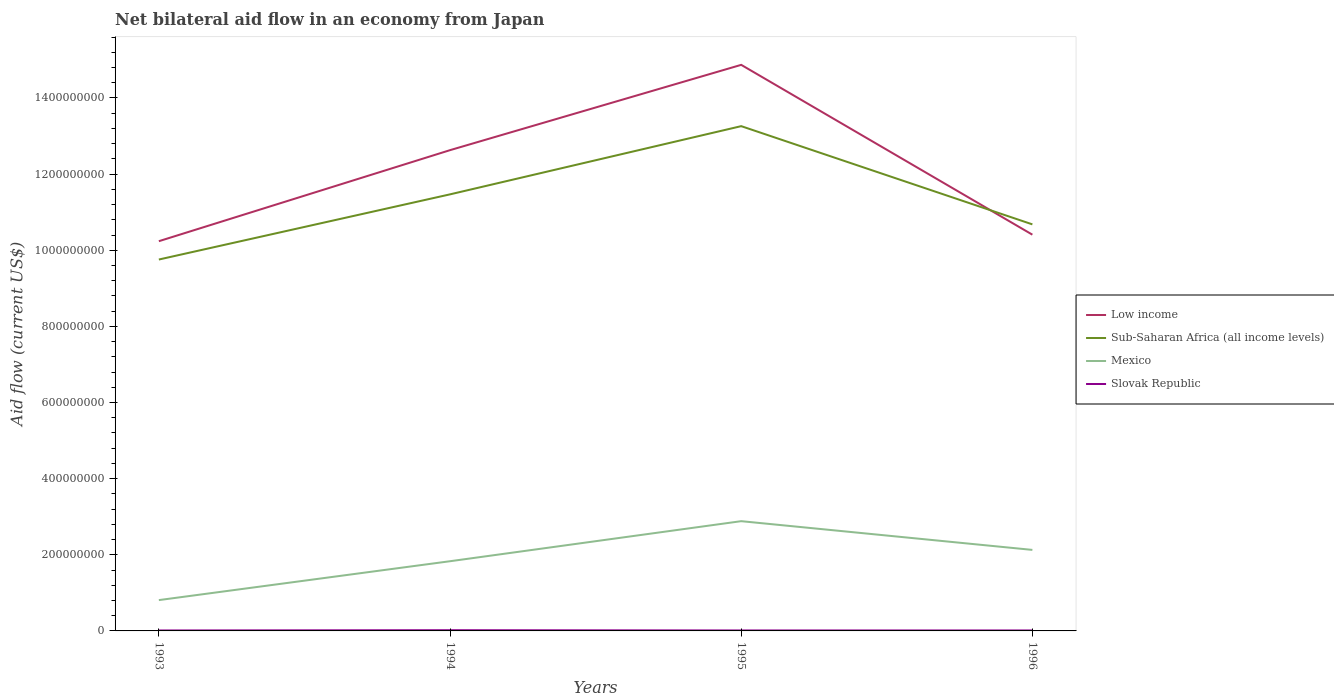Across all years, what is the maximum net bilateral aid flow in Slovak Republic?
Your response must be concise. 1.20e+06. What is the total net bilateral aid flow in Sub-Saharan Africa (all income levels) in the graph?
Keep it short and to the point. -3.50e+08. What is the difference between the highest and the second highest net bilateral aid flow in Mexico?
Your answer should be very brief. 2.07e+08. What is the difference between the highest and the lowest net bilateral aid flow in Mexico?
Make the answer very short. 2. What is the difference between two consecutive major ticks on the Y-axis?
Offer a very short reply. 2.00e+08. Are the values on the major ticks of Y-axis written in scientific E-notation?
Ensure brevity in your answer.  No. How many legend labels are there?
Offer a very short reply. 4. How are the legend labels stacked?
Give a very brief answer. Vertical. What is the title of the graph?
Make the answer very short. Net bilateral aid flow in an economy from Japan. Does "Peru" appear as one of the legend labels in the graph?
Provide a short and direct response. No. What is the label or title of the Y-axis?
Ensure brevity in your answer.  Aid flow (current US$). What is the Aid flow (current US$) in Low income in 1993?
Give a very brief answer. 1.02e+09. What is the Aid flow (current US$) of Sub-Saharan Africa (all income levels) in 1993?
Offer a terse response. 9.76e+08. What is the Aid flow (current US$) of Mexico in 1993?
Keep it short and to the point. 8.09e+07. What is the Aid flow (current US$) of Slovak Republic in 1993?
Offer a terse response. 1.20e+06. What is the Aid flow (current US$) in Low income in 1994?
Your answer should be very brief. 1.26e+09. What is the Aid flow (current US$) of Sub-Saharan Africa (all income levels) in 1994?
Provide a short and direct response. 1.15e+09. What is the Aid flow (current US$) of Mexico in 1994?
Offer a very short reply. 1.83e+08. What is the Aid flow (current US$) of Slovak Republic in 1994?
Your response must be concise. 1.89e+06. What is the Aid flow (current US$) in Low income in 1995?
Your response must be concise. 1.49e+09. What is the Aid flow (current US$) in Sub-Saharan Africa (all income levels) in 1995?
Provide a succinct answer. 1.33e+09. What is the Aid flow (current US$) of Mexico in 1995?
Keep it short and to the point. 2.88e+08. What is the Aid flow (current US$) in Slovak Republic in 1995?
Your answer should be compact. 1.24e+06. What is the Aid flow (current US$) in Low income in 1996?
Offer a very short reply. 1.04e+09. What is the Aid flow (current US$) in Sub-Saharan Africa (all income levels) in 1996?
Your answer should be compact. 1.07e+09. What is the Aid flow (current US$) in Mexico in 1996?
Keep it short and to the point. 2.13e+08. What is the Aid flow (current US$) of Slovak Republic in 1996?
Your answer should be compact. 1.22e+06. Across all years, what is the maximum Aid flow (current US$) of Low income?
Provide a short and direct response. 1.49e+09. Across all years, what is the maximum Aid flow (current US$) in Sub-Saharan Africa (all income levels)?
Offer a very short reply. 1.33e+09. Across all years, what is the maximum Aid flow (current US$) of Mexico?
Offer a very short reply. 2.88e+08. Across all years, what is the maximum Aid flow (current US$) in Slovak Republic?
Your answer should be compact. 1.89e+06. Across all years, what is the minimum Aid flow (current US$) of Low income?
Give a very brief answer. 1.02e+09. Across all years, what is the minimum Aid flow (current US$) of Sub-Saharan Africa (all income levels)?
Make the answer very short. 9.76e+08. Across all years, what is the minimum Aid flow (current US$) of Mexico?
Your response must be concise. 8.09e+07. Across all years, what is the minimum Aid flow (current US$) of Slovak Republic?
Provide a succinct answer. 1.20e+06. What is the total Aid flow (current US$) of Low income in the graph?
Offer a terse response. 4.81e+09. What is the total Aid flow (current US$) in Sub-Saharan Africa (all income levels) in the graph?
Offer a very short reply. 4.52e+09. What is the total Aid flow (current US$) in Mexico in the graph?
Keep it short and to the point. 7.65e+08. What is the total Aid flow (current US$) in Slovak Republic in the graph?
Make the answer very short. 5.55e+06. What is the difference between the Aid flow (current US$) in Low income in 1993 and that in 1994?
Your answer should be compact. -2.39e+08. What is the difference between the Aid flow (current US$) in Sub-Saharan Africa (all income levels) in 1993 and that in 1994?
Your answer should be compact. -1.71e+08. What is the difference between the Aid flow (current US$) of Mexico in 1993 and that in 1994?
Provide a short and direct response. -1.02e+08. What is the difference between the Aid flow (current US$) of Slovak Republic in 1993 and that in 1994?
Your answer should be compact. -6.90e+05. What is the difference between the Aid flow (current US$) in Low income in 1993 and that in 1995?
Give a very brief answer. -4.63e+08. What is the difference between the Aid flow (current US$) of Sub-Saharan Africa (all income levels) in 1993 and that in 1995?
Provide a short and direct response. -3.50e+08. What is the difference between the Aid flow (current US$) of Mexico in 1993 and that in 1995?
Provide a short and direct response. -2.07e+08. What is the difference between the Aid flow (current US$) in Slovak Republic in 1993 and that in 1995?
Offer a terse response. -4.00e+04. What is the difference between the Aid flow (current US$) in Low income in 1993 and that in 1996?
Provide a short and direct response. -1.71e+07. What is the difference between the Aid flow (current US$) of Sub-Saharan Africa (all income levels) in 1993 and that in 1996?
Give a very brief answer. -9.23e+07. What is the difference between the Aid flow (current US$) of Mexico in 1993 and that in 1996?
Ensure brevity in your answer.  -1.32e+08. What is the difference between the Aid flow (current US$) of Slovak Republic in 1993 and that in 1996?
Ensure brevity in your answer.  -2.00e+04. What is the difference between the Aid flow (current US$) in Low income in 1994 and that in 1995?
Offer a very short reply. -2.24e+08. What is the difference between the Aid flow (current US$) of Sub-Saharan Africa (all income levels) in 1994 and that in 1995?
Make the answer very short. -1.79e+08. What is the difference between the Aid flow (current US$) in Mexico in 1994 and that in 1995?
Keep it short and to the point. -1.05e+08. What is the difference between the Aid flow (current US$) in Slovak Republic in 1994 and that in 1995?
Your answer should be compact. 6.50e+05. What is the difference between the Aid flow (current US$) in Low income in 1994 and that in 1996?
Keep it short and to the point. 2.22e+08. What is the difference between the Aid flow (current US$) in Sub-Saharan Africa (all income levels) in 1994 and that in 1996?
Offer a very short reply. 7.88e+07. What is the difference between the Aid flow (current US$) in Mexico in 1994 and that in 1996?
Your answer should be compact. -2.98e+07. What is the difference between the Aid flow (current US$) in Slovak Republic in 1994 and that in 1996?
Give a very brief answer. 6.70e+05. What is the difference between the Aid flow (current US$) of Low income in 1995 and that in 1996?
Keep it short and to the point. 4.46e+08. What is the difference between the Aid flow (current US$) in Sub-Saharan Africa (all income levels) in 1995 and that in 1996?
Provide a short and direct response. 2.58e+08. What is the difference between the Aid flow (current US$) of Mexico in 1995 and that in 1996?
Make the answer very short. 7.54e+07. What is the difference between the Aid flow (current US$) of Low income in 1993 and the Aid flow (current US$) of Sub-Saharan Africa (all income levels) in 1994?
Ensure brevity in your answer.  -1.23e+08. What is the difference between the Aid flow (current US$) in Low income in 1993 and the Aid flow (current US$) in Mexico in 1994?
Keep it short and to the point. 8.41e+08. What is the difference between the Aid flow (current US$) in Low income in 1993 and the Aid flow (current US$) in Slovak Republic in 1994?
Your answer should be very brief. 1.02e+09. What is the difference between the Aid flow (current US$) of Sub-Saharan Africa (all income levels) in 1993 and the Aid flow (current US$) of Mexico in 1994?
Provide a succinct answer. 7.93e+08. What is the difference between the Aid flow (current US$) in Sub-Saharan Africa (all income levels) in 1993 and the Aid flow (current US$) in Slovak Republic in 1994?
Offer a terse response. 9.74e+08. What is the difference between the Aid flow (current US$) of Mexico in 1993 and the Aid flow (current US$) of Slovak Republic in 1994?
Your answer should be very brief. 7.90e+07. What is the difference between the Aid flow (current US$) of Low income in 1993 and the Aid flow (current US$) of Sub-Saharan Africa (all income levels) in 1995?
Your response must be concise. -3.02e+08. What is the difference between the Aid flow (current US$) in Low income in 1993 and the Aid flow (current US$) in Mexico in 1995?
Provide a succinct answer. 7.35e+08. What is the difference between the Aid flow (current US$) in Low income in 1993 and the Aid flow (current US$) in Slovak Republic in 1995?
Make the answer very short. 1.02e+09. What is the difference between the Aid flow (current US$) in Sub-Saharan Africa (all income levels) in 1993 and the Aid flow (current US$) in Mexico in 1995?
Provide a succinct answer. 6.87e+08. What is the difference between the Aid flow (current US$) of Sub-Saharan Africa (all income levels) in 1993 and the Aid flow (current US$) of Slovak Republic in 1995?
Your answer should be compact. 9.74e+08. What is the difference between the Aid flow (current US$) of Mexico in 1993 and the Aid flow (current US$) of Slovak Republic in 1995?
Your answer should be compact. 7.97e+07. What is the difference between the Aid flow (current US$) in Low income in 1993 and the Aid flow (current US$) in Sub-Saharan Africa (all income levels) in 1996?
Provide a short and direct response. -4.42e+07. What is the difference between the Aid flow (current US$) in Low income in 1993 and the Aid flow (current US$) in Mexico in 1996?
Give a very brief answer. 8.11e+08. What is the difference between the Aid flow (current US$) in Low income in 1993 and the Aid flow (current US$) in Slovak Republic in 1996?
Keep it short and to the point. 1.02e+09. What is the difference between the Aid flow (current US$) of Sub-Saharan Africa (all income levels) in 1993 and the Aid flow (current US$) of Mexico in 1996?
Provide a succinct answer. 7.63e+08. What is the difference between the Aid flow (current US$) of Sub-Saharan Africa (all income levels) in 1993 and the Aid flow (current US$) of Slovak Republic in 1996?
Provide a succinct answer. 9.74e+08. What is the difference between the Aid flow (current US$) in Mexico in 1993 and the Aid flow (current US$) in Slovak Republic in 1996?
Keep it short and to the point. 7.97e+07. What is the difference between the Aid flow (current US$) in Low income in 1994 and the Aid flow (current US$) in Sub-Saharan Africa (all income levels) in 1995?
Offer a terse response. -6.30e+07. What is the difference between the Aid flow (current US$) in Low income in 1994 and the Aid flow (current US$) in Mexico in 1995?
Provide a succinct answer. 9.75e+08. What is the difference between the Aid flow (current US$) in Low income in 1994 and the Aid flow (current US$) in Slovak Republic in 1995?
Provide a succinct answer. 1.26e+09. What is the difference between the Aid flow (current US$) in Sub-Saharan Africa (all income levels) in 1994 and the Aid flow (current US$) in Mexico in 1995?
Your answer should be very brief. 8.58e+08. What is the difference between the Aid flow (current US$) of Sub-Saharan Africa (all income levels) in 1994 and the Aid flow (current US$) of Slovak Republic in 1995?
Your response must be concise. 1.15e+09. What is the difference between the Aid flow (current US$) in Mexico in 1994 and the Aid flow (current US$) in Slovak Republic in 1995?
Provide a short and direct response. 1.82e+08. What is the difference between the Aid flow (current US$) of Low income in 1994 and the Aid flow (current US$) of Sub-Saharan Africa (all income levels) in 1996?
Keep it short and to the point. 1.95e+08. What is the difference between the Aid flow (current US$) of Low income in 1994 and the Aid flow (current US$) of Mexico in 1996?
Your answer should be compact. 1.05e+09. What is the difference between the Aid flow (current US$) of Low income in 1994 and the Aid flow (current US$) of Slovak Republic in 1996?
Your answer should be very brief. 1.26e+09. What is the difference between the Aid flow (current US$) of Sub-Saharan Africa (all income levels) in 1994 and the Aid flow (current US$) of Mexico in 1996?
Provide a short and direct response. 9.34e+08. What is the difference between the Aid flow (current US$) of Sub-Saharan Africa (all income levels) in 1994 and the Aid flow (current US$) of Slovak Republic in 1996?
Offer a terse response. 1.15e+09. What is the difference between the Aid flow (current US$) in Mexico in 1994 and the Aid flow (current US$) in Slovak Republic in 1996?
Your response must be concise. 1.82e+08. What is the difference between the Aid flow (current US$) in Low income in 1995 and the Aid flow (current US$) in Sub-Saharan Africa (all income levels) in 1996?
Offer a very short reply. 4.19e+08. What is the difference between the Aid flow (current US$) in Low income in 1995 and the Aid flow (current US$) in Mexico in 1996?
Offer a very short reply. 1.27e+09. What is the difference between the Aid flow (current US$) of Low income in 1995 and the Aid flow (current US$) of Slovak Republic in 1996?
Your answer should be very brief. 1.49e+09. What is the difference between the Aid flow (current US$) of Sub-Saharan Africa (all income levels) in 1995 and the Aid flow (current US$) of Mexico in 1996?
Your response must be concise. 1.11e+09. What is the difference between the Aid flow (current US$) of Sub-Saharan Africa (all income levels) in 1995 and the Aid flow (current US$) of Slovak Republic in 1996?
Make the answer very short. 1.32e+09. What is the difference between the Aid flow (current US$) in Mexico in 1995 and the Aid flow (current US$) in Slovak Republic in 1996?
Offer a very short reply. 2.87e+08. What is the average Aid flow (current US$) in Low income per year?
Give a very brief answer. 1.20e+09. What is the average Aid flow (current US$) in Sub-Saharan Africa (all income levels) per year?
Your response must be concise. 1.13e+09. What is the average Aid flow (current US$) of Mexico per year?
Give a very brief answer. 1.91e+08. What is the average Aid flow (current US$) of Slovak Republic per year?
Provide a succinct answer. 1.39e+06. In the year 1993, what is the difference between the Aid flow (current US$) in Low income and Aid flow (current US$) in Sub-Saharan Africa (all income levels)?
Ensure brevity in your answer.  4.81e+07. In the year 1993, what is the difference between the Aid flow (current US$) of Low income and Aid flow (current US$) of Mexico?
Offer a very short reply. 9.43e+08. In the year 1993, what is the difference between the Aid flow (current US$) of Low income and Aid flow (current US$) of Slovak Republic?
Offer a terse response. 1.02e+09. In the year 1993, what is the difference between the Aid flow (current US$) of Sub-Saharan Africa (all income levels) and Aid flow (current US$) of Mexico?
Ensure brevity in your answer.  8.95e+08. In the year 1993, what is the difference between the Aid flow (current US$) of Sub-Saharan Africa (all income levels) and Aid flow (current US$) of Slovak Republic?
Provide a succinct answer. 9.74e+08. In the year 1993, what is the difference between the Aid flow (current US$) in Mexico and Aid flow (current US$) in Slovak Republic?
Ensure brevity in your answer.  7.97e+07. In the year 1994, what is the difference between the Aid flow (current US$) of Low income and Aid flow (current US$) of Sub-Saharan Africa (all income levels)?
Your answer should be compact. 1.16e+08. In the year 1994, what is the difference between the Aid flow (current US$) of Low income and Aid flow (current US$) of Mexico?
Provide a short and direct response. 1.08e+09. In the year 1994, what is the difference between the Aid flow (current US$) of Low income and Aid flow (current US$) of Slovak Republic?
Give a very brief answer. 1.26e+09. In the year 1994, what is the difference between the Aid flow (current US$) of Sub-Saharan Africa (all income levels) and Aid flow (current US$) of Mexico?
Keep it short and to the point. 9.64e+08. In the year 1994, what is the difference between the Aid flow (current US$) in Sub-Saharan Africa (all income levels) and Aid flow (current US$) in Slovak Republic?
Your answer should be compact. 1.14e+09. In the year 1994, what is the difference between the Aid flow (current US$) in Mexico and Aid flow (current US$) in Slovak Republic?
Your response must be concise. 1.81e+08. In the year 1995, what is the difference between the Aid flow (current US$) of Low income and Aid flow (current US$) of Sub-Saharan Africa (all income levels)?
Provide a short and direct response. 1.61e+08. In the year 1995, what is the difference between the Aid flow (current US$) in Low income and Aid flow (current US$) in Mexico?
Provide a short and direct response. 1.20e+09. In the year 1995, what is the difference between the Aid flow (current US$) of Low income and Aid flow (current US$) of Slovak Republic?
Provide a succinct answer. 1.49e+09. In the year 1995, what is the difference between the Aid flow (current US$) in Sub-Saharan Africa (all income levels) and Aid flow (current US$) in Mexico?
Ensure brevity in your answer.  1.04e+09. In the year 1995, what is the difference between the Aid flow (current US$) of Sub-Saharan Africa (all income levels) and Aid flow (current US$) of Slovak Republic?
Offer a very short reply. 1.32e+09. In the year 1995, what is the difference between the Aid flow (current US$) of Mexico and Aid flow (current US$) of Slovak Republic?
Your answer should be compact. 2.87e+08. In the year 1996, what is the difference between the Aid flow (current US$) in Low income and Aid flow (current US$) in Sub-Saharan Africa (all income levels)?
Make the answer very short. -2.71e+07. In the year 1996, what is the difference between the Aid flow (current US$) in Low income and Aid flow (current US$) in Mexico?
Make the answer very short. 8.28e+08. In the year 1996, what is the difference between the Aid flow (current US$) of Low income and Aid flow (current US$) of Slovak Republic?
Give a very brief answer. 1.04e+09. In the year 1996, what is the difference between the Aid flow (current US$) of Sub-Saharan Africa (all income levels) and Aid flow (current US$) of Mexico?
Offer a very short reply. 8.55e+08. In the year 1996, what is the difference between the Aid flow (current US$) of Sub-Saharan Africa (all income levels) and Aid flow (current US$) of Slovak Republic?
Offer a very short reply. 1.07e+09. In the year 1996, what is the difference between the Aid flow (current US$) of Mexico and Aid flow (current US$) of Slovak Republic?
Make the answer very short. 2.12e+08. What is the ratio of the Aid flow (current US$) of Low income in 1993 to that in 1994?
Keep it short and to the point. 0.81. What is the ratio of the Aid flow (current US$) of Sub-Saharan Africa (all income levels) in 1993 to that in 1994?
Your answer should be compact. 0.85. What is the ratio of the Aid flow (current US$) in Mexico in 1993 to that in 1994?
Your answer should be very brief. 0.44. What is the ratio of the Aid flow (current US$) of Slovak Republic in 1993 to that in 1994?
Offer a terse response. 0.63. What is the ratio of the Aid flow (current US$) of Low income in 1993 to that in 1995?
Your answer should be compact. 0.69. What is the ratio of the Aid flow (current US$) in Sub-Saharan Africa (all income levels) in 1993 to that in 1995?
Your response must be concise. 0.74. What is the ratio of the Aid flow (current US$) of Mexico in 1993 to that in 1995?
Keep it short and to the point. 0.28. What is the ratio of the Aid flow (current US$) in Low income in 1993 to that in 1996?
Keep it short and to the point. 0.98. What is the ratio of the Aid flow (current US$) in Sub-Saharan Africa (all income levels) in 1993 to that in 1996?
Ensure brevity in your answer.  0.91. What is the ratio of the Aid flow (current US$) of Mexico in 1993 to that in 1996?
Your answer should be very brief. 0.38. What is the ratio of the Aid flow (current US$) in Slovak Republic in 1993 to that in 1996?
Make the answer very short. 0.98. What is the ratio of the Aid flow (current US$) in Low income in 1994 to that in 1995?
Your answer should be very brief. 0.85. What is the ratio of the Aid flow (current US$) of Sub-Saharan Africa (all income levels) in 1994 to that in 1995?
Offer a terse response. 0.86. What is the ratio of the Aid flow (current US$) of Mexico in 1994 to that in 1995?
Offer a terse response. 0.64. What is the ratio of the Aid flow (current US$) of Slovak Republic in 1994 to that in 1995?
Your answer should be compact. 1.52. What is the ratio of the Aid flow (current US$) of Low income in 1994 to that in 1996?
Keep it short and to the point. 1.21. What is the ratio of the Aid flow (current US$) of Sub-Saharan Africa (all income levels) in 1994 to that in 1996?
Ensure brevity in your answer.  1.07. What is the ratio of the Aid flow (current US$) of Mexico in 1994 to that in 1996?
Make the answer very short. 0.86. What is the ratio of the Aid flow (current US$) of Slovak Republic in 1994 to that in 1996?
Provide a short and direct response. 1.55. What is the ratio of the Aid flow (current US$) in Low income in 1995 to that in 1996?
Offer a terse response. 1.43. What is the ratio of the Aid flow (current US$) in Sub-Saharan Africa (all income levels) in 1995 to that in 1996?
Provide a short and direct response. 1.24. What is the ratio of the Aid flow (current US$) in Mexico in 1995 to that in 1996?
Keep it short and to the point. 1.35. What is the ratio of the Aid flow (current US$) of Slovak Republic in 1995 to that in 1996?
Provide a succinct answer. 1.02. What is the difference between the highest and the second highest Aid flow (current US$) of Low income?
Give a very brief answer. 2.24e+08. What is the difference between the highest and the second highest Aid flow (current US$) of Sub-Saharan Africa (all income levels)?
Offer a terse response. 1.79e+08. What is the difference between the highest and the second highest Aid flow (current US$) of Mexico?
Your answer should be compact. 7.54e+07. What is the difference between the highest and the second highest Aid flow (current US$) of Slovak Republic?
Your answer should be very brief. 6.50e+05. What is the difference between the highest and the lowest Aid flow (current US$) of Low income?
Your answer should be very brief. 4.63e+08. What is the difference between the highest and the lowest Aid flow (current US$) in Sub-Saharan Africa (all income levels)?
Offer a terse response. 3.50e+08. What is the difference between the highest and the lowest Aid flow (current US$) in Mexico?
Your answer should be very brief. 2.07e+08. What is the difference between the highest and the lowest Aid flow (current US$) in Slovak Republic?
Give a very brief answer. 6.90e+05. 